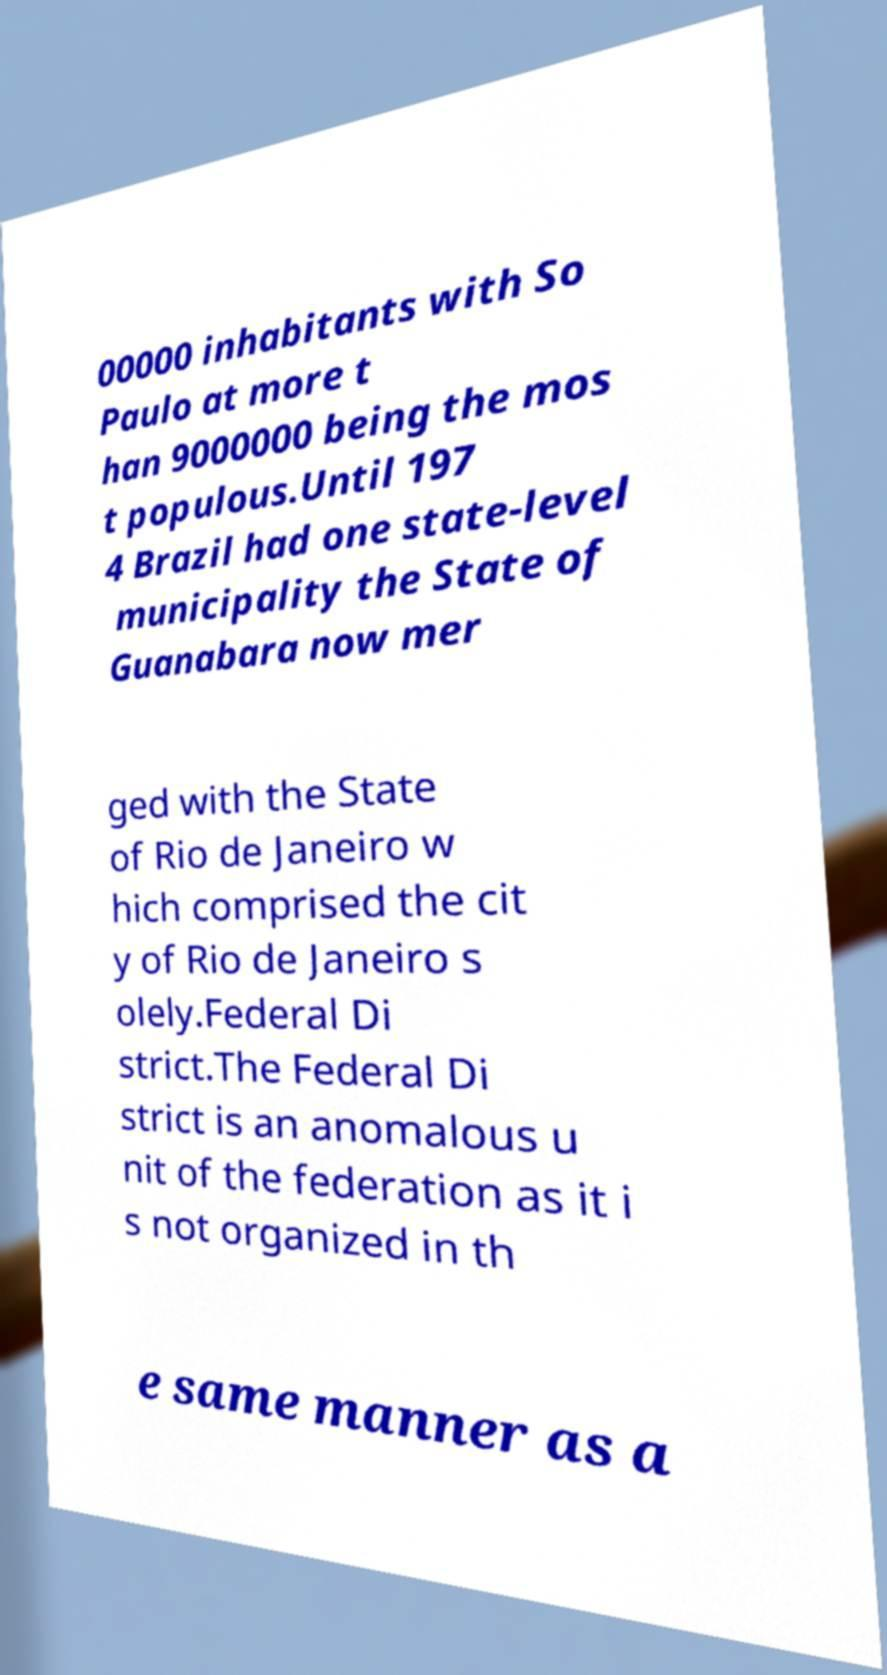Please read and relay the text visible in this image. What does it say? 00000 inhabitants with So Paulo at more t han 9000000 being the mos t populous.Until 197 4 Brazil had one state-level municipality the State of Guanabara now mer ged with the State of Rio de Janeiro w hich comprised the cit y of Rio de Janeiro s olely.Federal Di strict.The Federal Di strict is an anomalous u nit of the federation as it i s not organized in th e same manner as a 